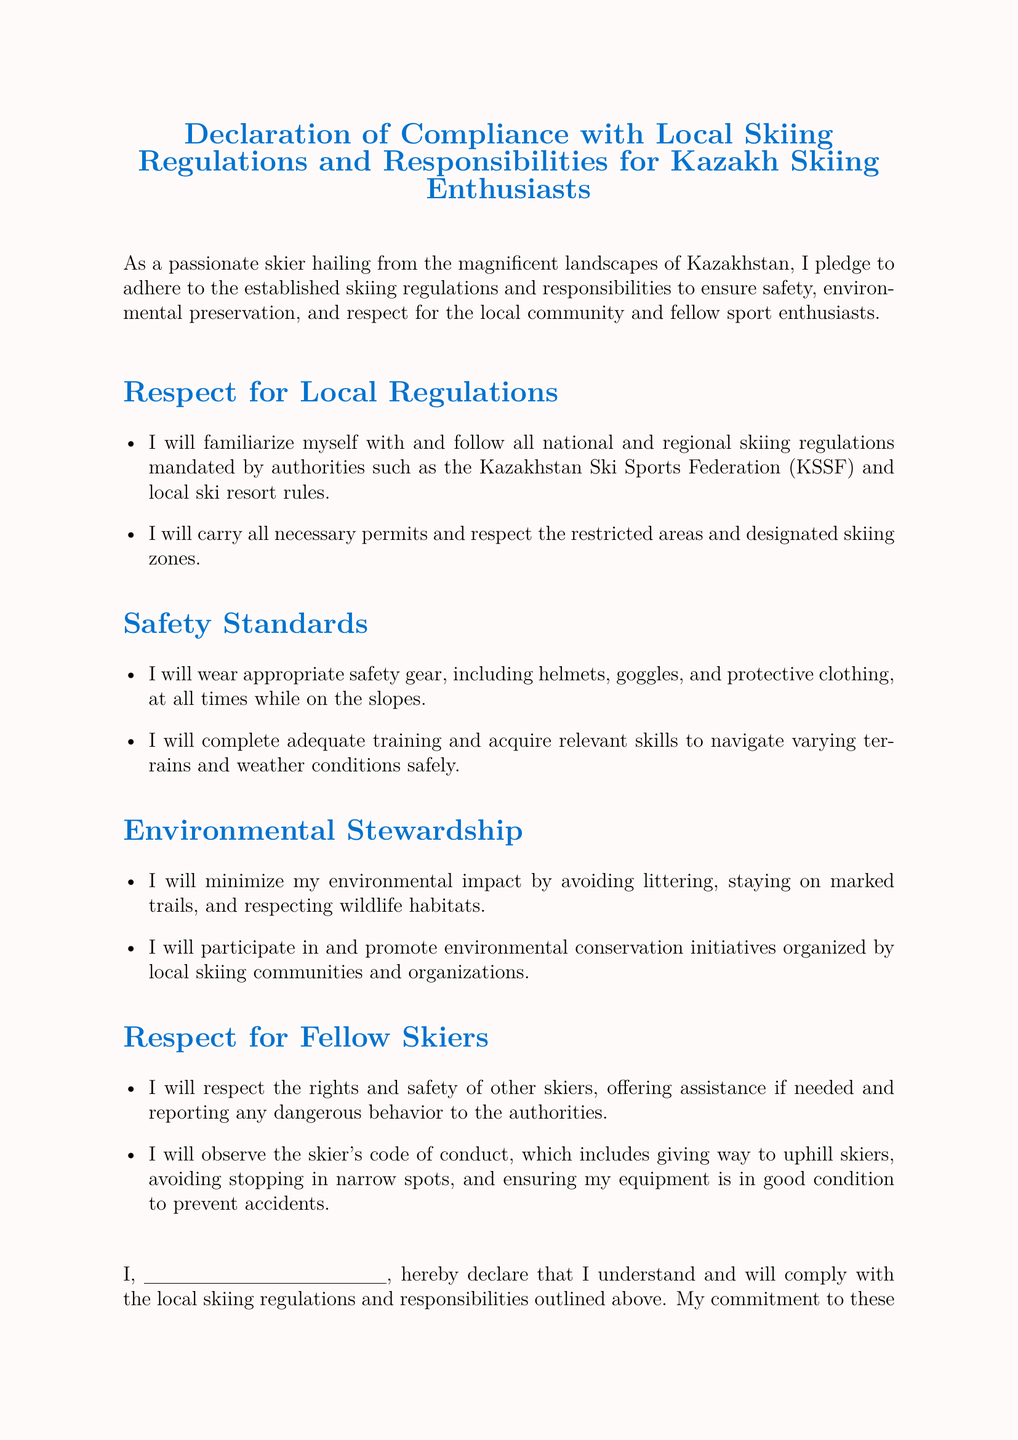What is the title of the document? The title is the main heading of the document that indicates its purpose and content.
Answer: Declaration of Compliance with Local Skiing Regulations and Responsibilities for Kazakh Skiing Enthusiasts Who is responsible for the regulations mentioned? The responsibility for adhering to the regulations is stated in the introduction portion of the document.
Answer: Kazakhstan Ski Sports Federation What should skiers wear for safety? The document specifies the type of safety gear that should be worn by skiers while on the slopes.
Answer: Helmets, goggles, and protective clothing What will the signer participate in according to environmental stewardship? The related section discusses the commitment to engage in certain initiatives concerning environmental conservation.
Answer: Environmental conservation initiatives What is the commitment of the signer based on? The signer expresses a personal commitment which reflects a specific aspect of their love for skiing.
Answer: Love for skiing and respect for the beautiful Kazakh winter landscapes What actions will skiers take towards respect for fellow skiers? This refers to the behaviors and attitudes that are expected from skiers regarding their interactions with others on the slopes.
Answer: Respect the rights and safety of other skiers What must skiers do if they see dangerous behavior? This question addresses the actions required from skiers when witnessing risky actions on the slopes.
Answer: Report any dangerous behavior to the authorities What is the date of the declaration? The document includes a space for entering a specific detail related to the time of signing.
Answer: Date: __________ 